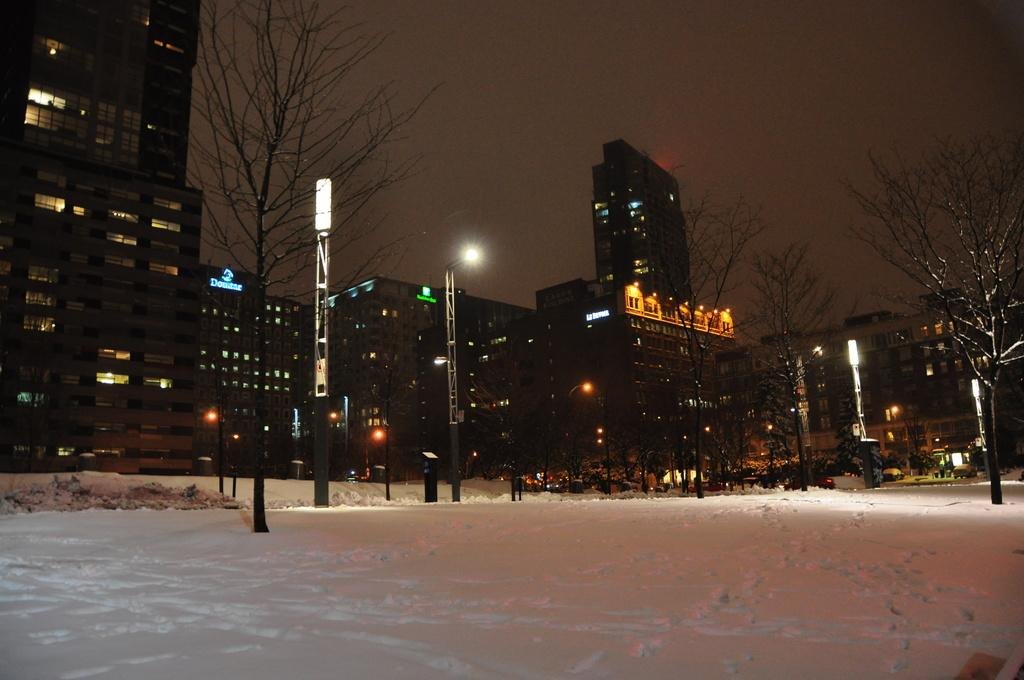What is the condition of the road in the image? The road is covered with snow in the image. What structures can be seen along the road? There are light poles in the image. What type of natural elements are present in the image? Trees are present in the image. What type of buildings can be seen in the image? Tower buildings are visible in the image. What is the color of the sky in the background? The sky in the background is dark in the image. Where is the stream located in the image? There is no stream present in the image. What type of cellar can be seen in the image? There is no cellar present in the image. 